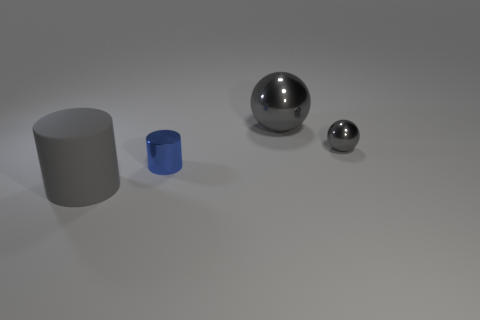What are the textures of the objects like? The objects exhibit smooth and reflective textures. The large sphere and tiny cylinder have highly reflective surfaces, suggesting they are made of a polished metal, while the cylinders show a matte finish. 